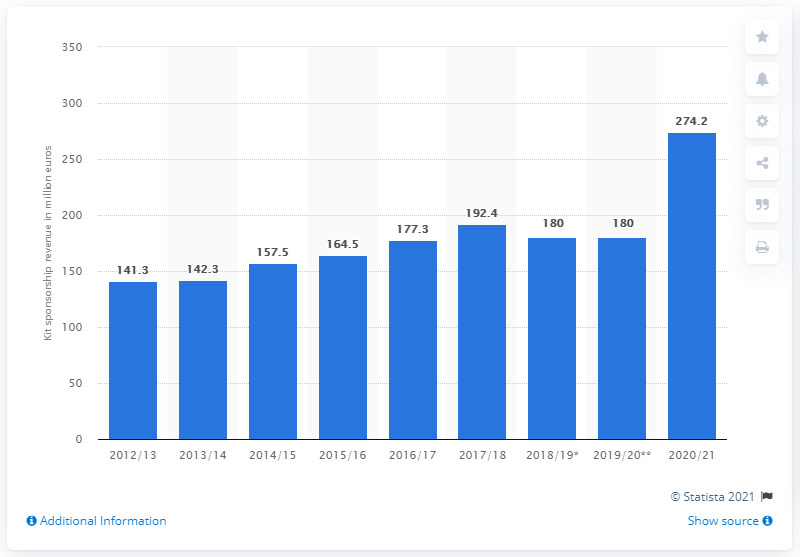Give some essential details in this illustration. The total revenue generated from kit sponsorships in the 2019/20 season was 274.2.. 